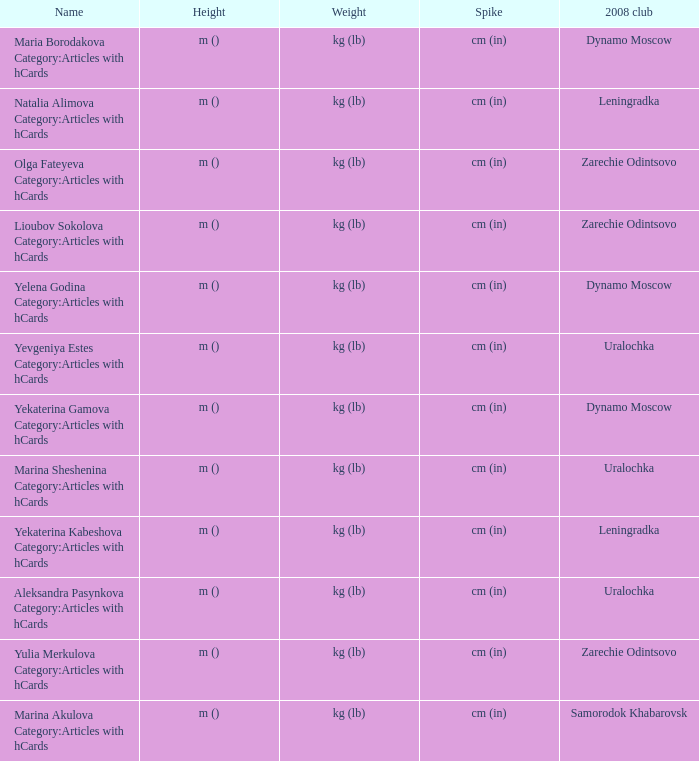What is the name of the 2008 club called zarechie odintsovo? Olga Fateyeva Category:Articles with hCards, Lioubov Sokolova Category:Articles with hCards, Yulia Merkulova Category:Articles with hCards. 